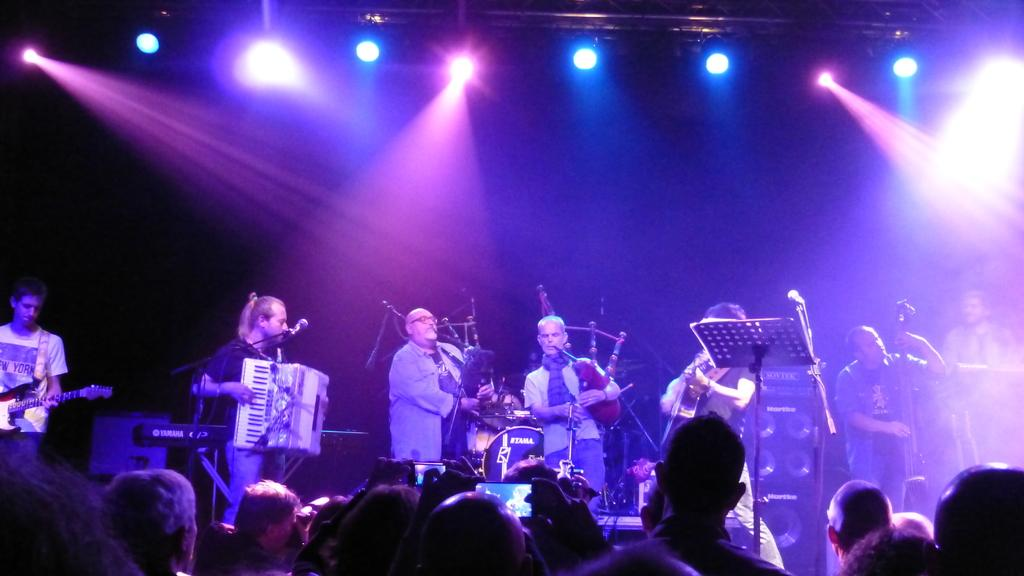What are the people in the image doing? The people in the image are standing and playing musical instruments. What is in front of the musicians? There is a microphone in front of the musicians. Are there any other people in the image besides the musicians? Yes, there are other people standing in front of the musicians. Reasoning: Let' Let's think step by step in order to produce the conversation. We start by identifying the main activity in the image, which is people playing musical instruments. Then, we describe the presence of a microphone in front of the musicians, which suggests that they are performing. Finally, we acknowledge the presence of other people in the image, who may be the audience or fellow performers. Absurd Question/Answer: What type of thumb can be seen playing the guitar in the image? There is no thumb playing the guitar in the image; it is the musicians' hands and fingers that are playing the instruments. 